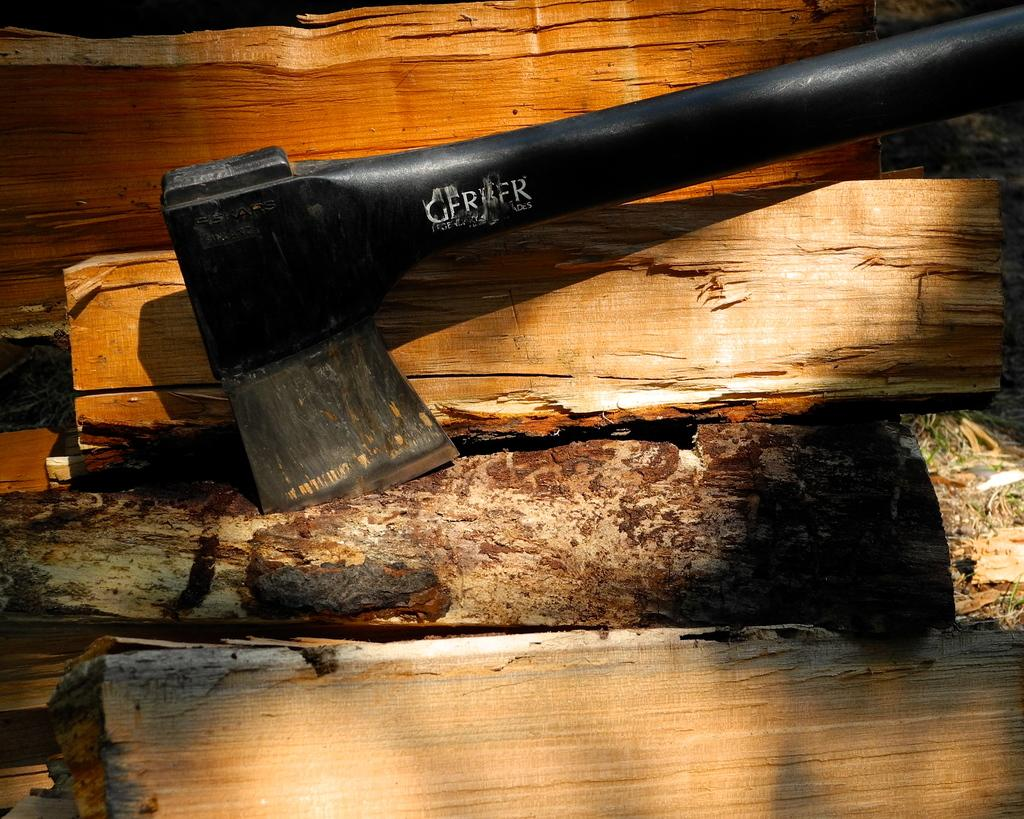What color is the axe in the image? The axe in the image is black. What material are the wooden pieces made of? The wooden pieces in the image are made of wood. What type of flowers can be seen growing in the middle of the image? There are no flowers present in the image; it features a black axe and wooden pieces. 